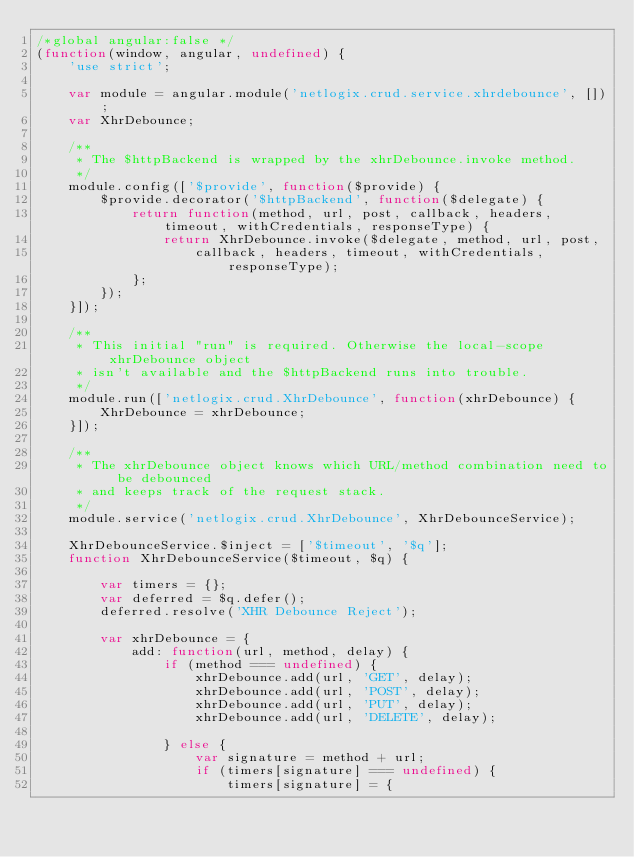<code> <loc_0><loc_0><loc_500><loc_500><_JavaScript_>/*global angular:false */
(function(window, angular, undefined) {
	'use strict';

	var module = angular.module('netlogix.crud.service.xhrdebounce', []);
	var XhrDebounce;

	/**
	 * The $httpBackend is wrapped by the xhrDebounce.invoke method.
	 */
	module.config(['$provide', function($provide) {
		$provide.decorator('$httpBackend', function($delegate) {
			return function(method, url, post, callback, headers, timeout, withCredentials, responseType) {
				return XhrDebounce.invoke($delegate, method, url, post,
					callback, headers, timeout, withCredentials, responseType);
			};
		});
	}]);

	/**
	 * This initial "run" is required. Otherwise the local-scope xhrDebounce object
	 * isn't available and the $httpBackend runs into trouble.
	 */
	module.run(['netlogix.crud.XhrDebounce', function(xhrDebounce) {
		XhrDebounce = xhrDebounce;
	}]);

	/**
	 * The xhrDebounce object knows which URL/method combination need to be debounced
	 * and keeps track of the request stack.
	 */
	module.service('netlogix.crud.XhrDebounce', XhrDebounceService);

	XhrDebounceService.$inject = ['$timeout', '$q'];
	function XhrDebounceService($timeout, $q) {

		var timers = {};
		var deferred = $q.defer();
		deferred.resolve('XHR Debounce Reject');

		var xhrDebounce = {
			add: function(url, method, delay) {
				if (method === undefined) {
					xhrDebounce.add(url, 'GET', delay);
					xhrDebounce.add(url, 'POST', delay);
					xhrDebounce.add(url, 'PUT', delay);
					xhrDebounce.add(url, 'DELETE', delay);

				} else {
					var signature = method + url;
					if (timers[signature] === undefined) {
						timers[signature] = {</code> 